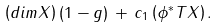<formula> <loc_0><loc_0><loc_500><loc_500>\left ( d i m X \right ) ( 1 - g ) \, + \, c _ { 1 } \left ( \phi ^ { * } T X \right ) .</formula> 